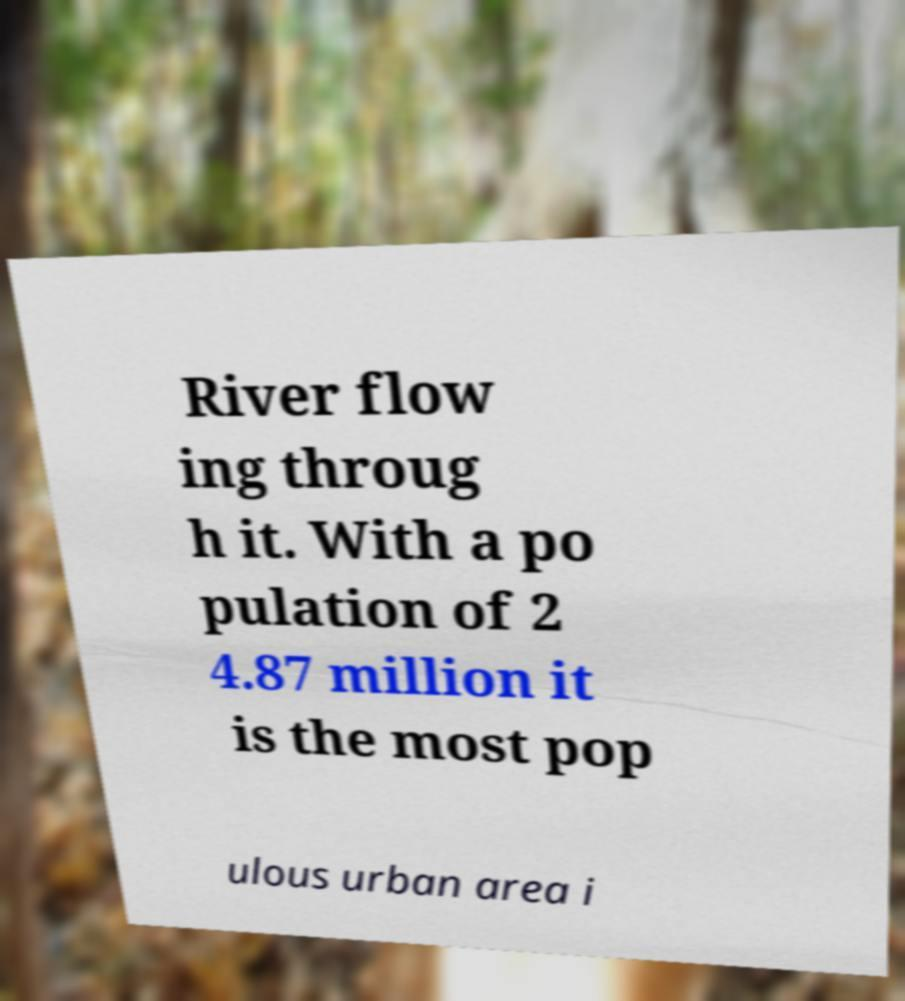There's text embedded in this image that I need extracted. Can you transcribe it verbatim? River flow ing throug h it. With a po pulation of 2 4.87 million it is the most pop ulous urban area i 